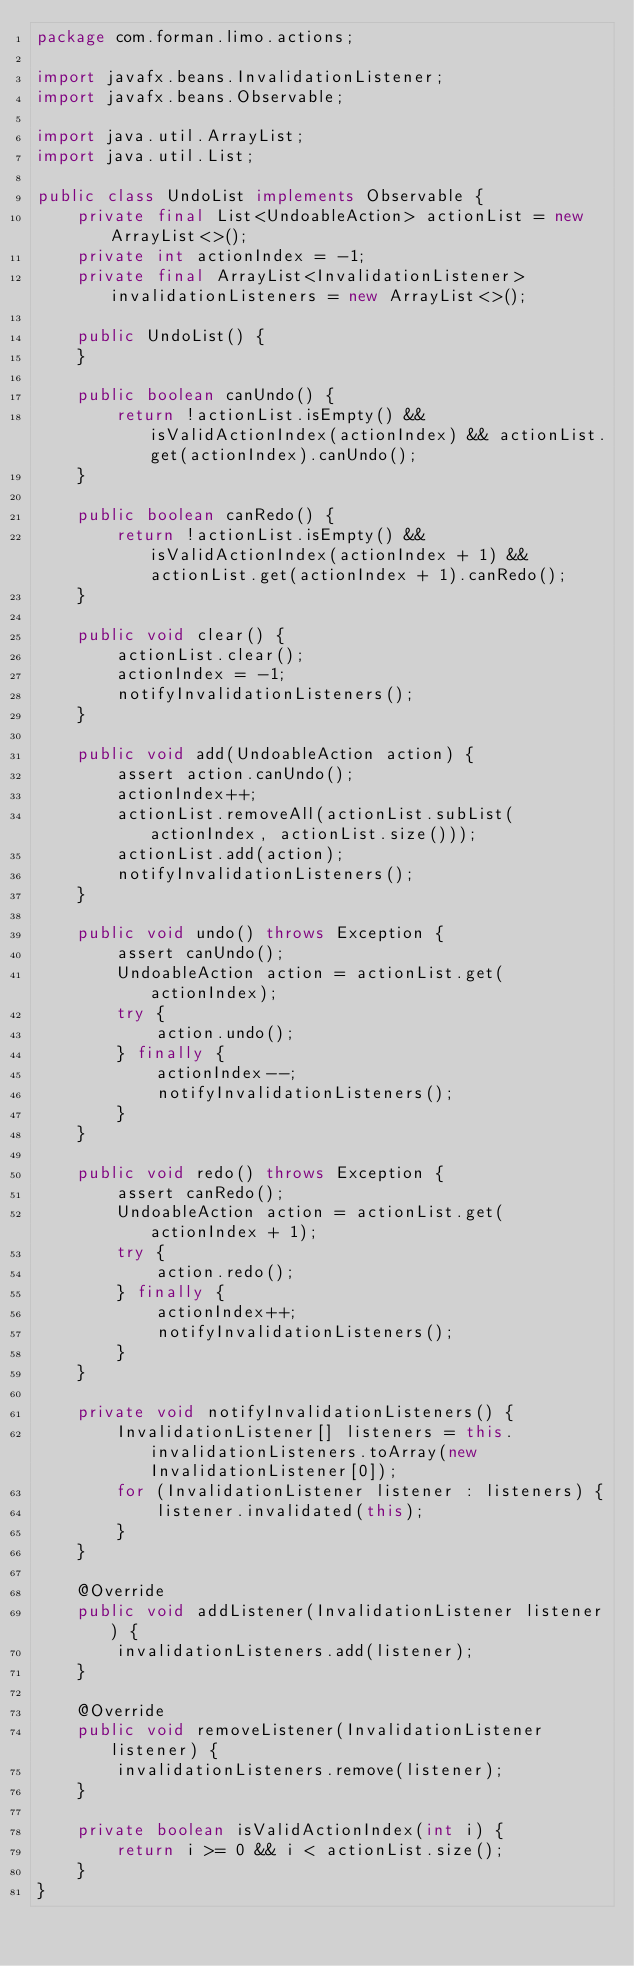<code> <loc_0><loc_0><loc_500><loc_500><_Java_>package com.forman.limo.actions;

import javafx.beans.InvalidationListener;
import javafx.beans.Observable;

import java.util.ArrayList;
import java.util.List;

public class UndoList implements Observable {
    private final List<UndoableAction> actionList = new ArrayList<>();
    private int actionIndex = -1;
    private final ArrayList<InvalidationListener> invalidationListeners = new ArrayList<>();

    public UndoList() {
    }

    public boolean canUndo() {
        return !actionList.isEmpty() && isValidActionIndex(actionIndex) && actionList.get(actionIndex).canUndo();
    }

    public boolean canRedo() {
        return !actionList.isEmpty() && isValidActionIndex(actionIndex + 1) && actionList.get(actionIndex + 1).canRedo();
    }

    public void clear() {
        actionList.clear();
        actionIndex = -1;
        notifyInvalidationListeners();
    }

    public void add(UndoableAction action) {
        assert action.canUndo();
        actionIndex++;
        actionList.removeAll(actionList.subList(actionIndex, actionList.size()));
        actionList.add(action);
        notifyInvalidationListeners();
    }

    public void undo() throws Exception {
        assert canUndo();
        UndoableAction action = actionList.get(actionIndex);
        try {
            action.undo();
        } finally {
            actionIndex--;
            notifyInvalidationListeners();
        }
    }

    public void redo() throws Exception {
        assert canRedo();
        UndoableAction action = actionList.get(actionIndex + 1);
        try {
            action.redo();
        } finally {
            actionIndex++;
            notifyInvalidationListeners();
        }
    }

    private void notifyInvalidationListeners() {
        InvalidationListener[] listeners = this.invalidationListeners.toArray(new InvalidationListener[0]);
        for (InvalidationListener listener : listeners) {
            listener.invalidated(this);
        }
    }

    @Override
    public void addListener(InvalidationListener listener) {
        invalidationListeners.add(listener);
    }

    @Override
    public void removeListener(InvalidationListener listener) {
        invalidationListeners.remove(listener);
    }

    private boolean isValidActionIndex(int i) {
        return i >= 0 && i < actionList.size();
    }
}
</code> 